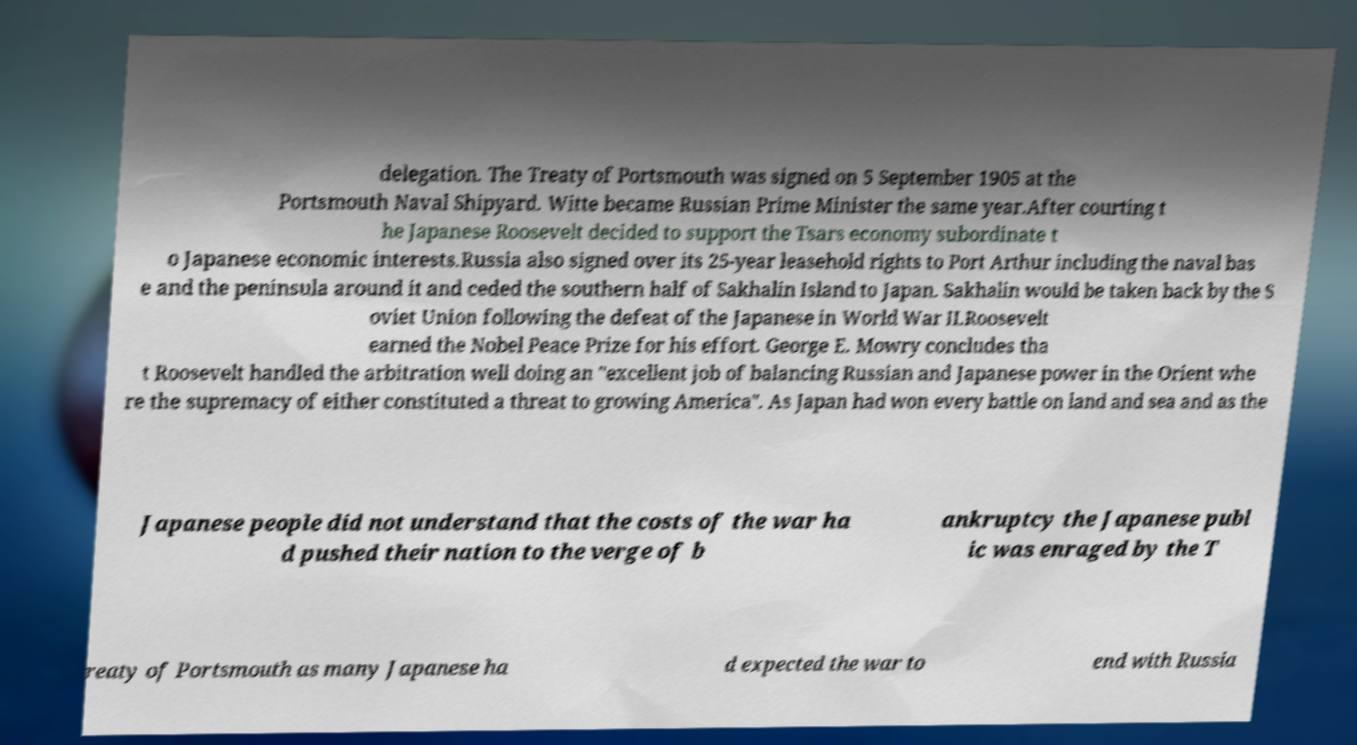I need the written content from this picture converted into text. Can you do that? delegation. The Treaty of Portsmouth was signed on 5 September 1905 at the Portsmouth Naval Shipyard. Witte became Russian Prime Minister the same year.After courting t he Japanese Roosevelt decided to support the Tsars economy subordinate t o Japanese economic interests.Russia also signed over its 25-year leasehold rights to Port Arthur including the naval bas e and the peninsula around it and ceded the southern half of Sakhalin Island to Japan. Sakhalin would be taken back by the S oviet Union following the defeat of the Japanese in World War II.Roosevelt earned the Nobel Peace Prize for his effort. George E. Mowry concludes tha t Roosevelt handled the arbitration well doing an "excellent job of balancing Russian and Japanese power in the Orient whe re the supremacy of either constituted a threat to growing America". As Japan had won every battle on land and sea and as the Japanese people did not understand that the costs of the war ha d pushed their nation to the verge of b ankruptcy the Japanese publ ic was enraged by the T reaty of Portsmouth as many Japanese ha d expected the war to end with Russia 